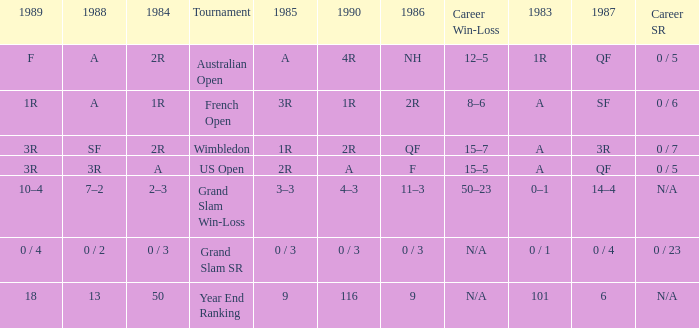What is the result in 1985 when the career win-loss is n/a, and 0 / 23 as the career SR? 0 / 3. 